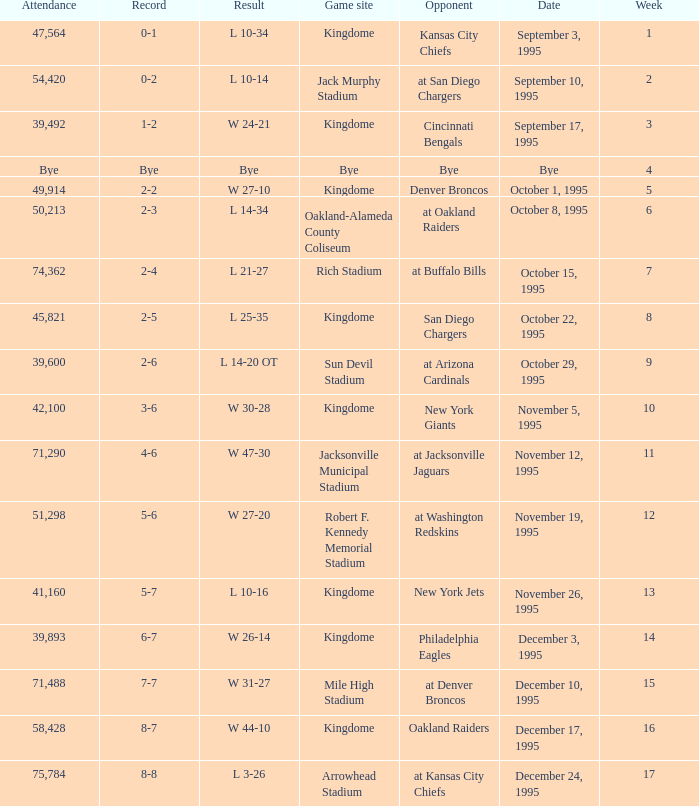Who was the opponent when the Seattle Seahawks had a record of 0-1? Kansas City Chiefs. 